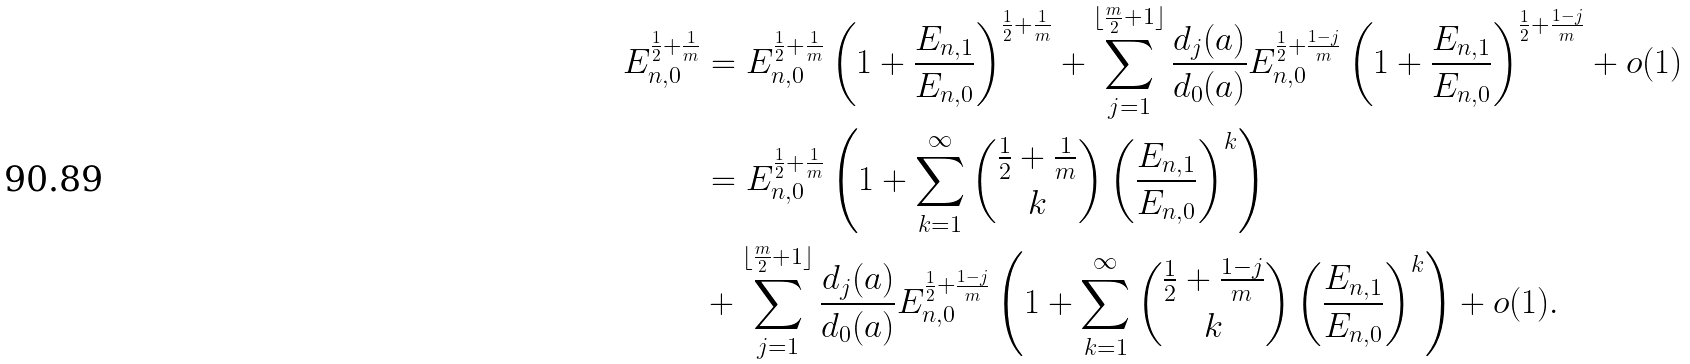Convert formula to latex. <formula><loc_0><loc_0><loc_500><loc_500>E _ { n , 0 } ^ { \frac { 1 } { 2 } + \frac { 1 } { m } } & = E _ { n , 0 } ^ { \frac { 1 } { 2 } + \frac { 1 } { m } } \left ( 1 + \frac { E _ { n , 1 } } { E _ { n , 0 } } \right ) ^ { \frac { 1 } { 2 } + \frac { 1 } { m } } + \sum _ { j = 1 } ^ { \lfloor \frac { m } { 2 } + 1 \rfloor } \frac { d _ { j } ( a ) } { d _ { 0 } ( a ) } E _ { n , 0 } ^ { \frac { 1 } { 2 } + \frac { 1 - j } { m } } \left ( 1 + \frac { E _ { n , 1 } } { E _ { n , 0 } } \right ) ^ { \frac { 1 } { 2 } + \frac { 1 - j } { m } } + o ( 1 ) \\ & = E _ { n , 0 } ^ { \frac { 1 } { 2 } + \frac { 1 } { m } } \left ( 1 + \sum _ { k = 1 } ^ { \infty } { \frac { 1 } { 2 } + \frac { 1 } { m } \choose k } \left ( \frac { E _ { n , 1 } } { E _ { n , 0 } } \right ) ^ { k } \right ) \\ & + \sum _ { j = 1 } ^ { \lfloor \frac { m } { 2 } + 1 \rfloor } \frac { d _ { j } ( a ) } { d _ { 0 } ( a ) } E _ { n , 0 } ^ { \frac { 1 } { 2 } + \frac { 1 - j } { m } } \left ( 1 + \sum _ { k = 1 } ^ { \infty } { \frac { 1 } { 2 } + \frac { 1 - j } { m } \choose k } \left ( \frac { E _ { n , 1 } } { E _ { n , 0 } } \right ) ^ { k } \right ) + o ( 1 ) .</formula> 